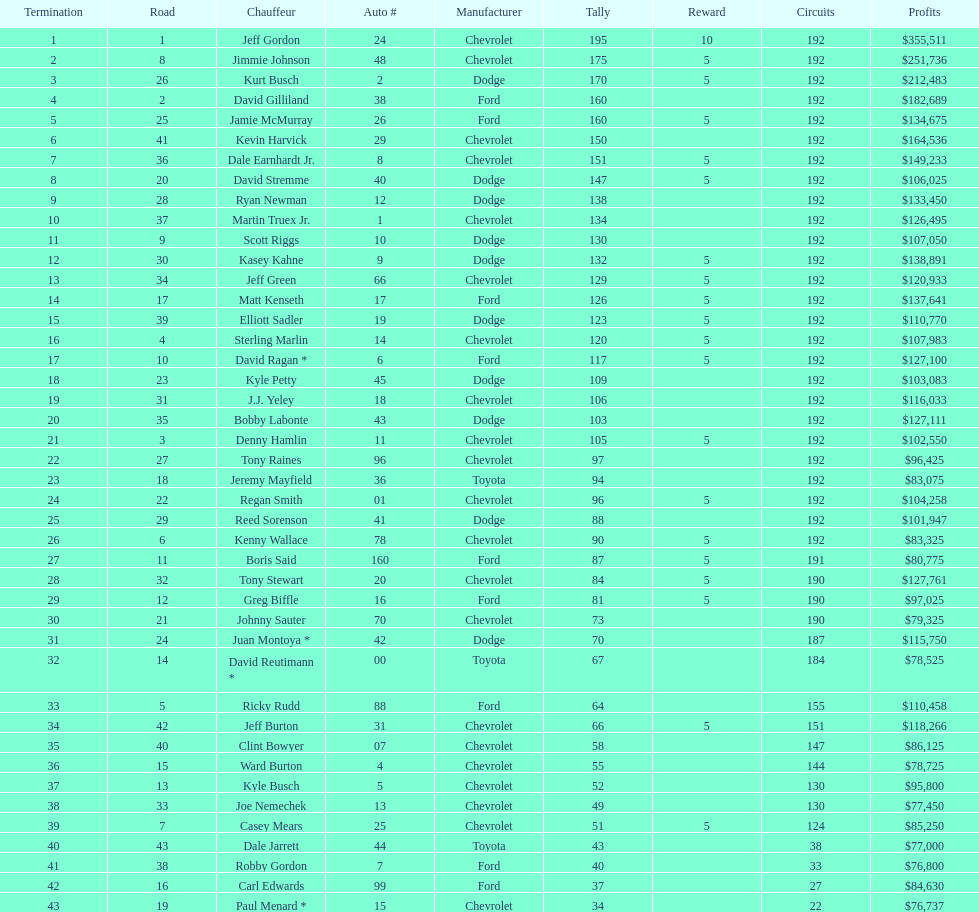Which make had the most consecutive finishes at the aarons 499? Chevrolet. 